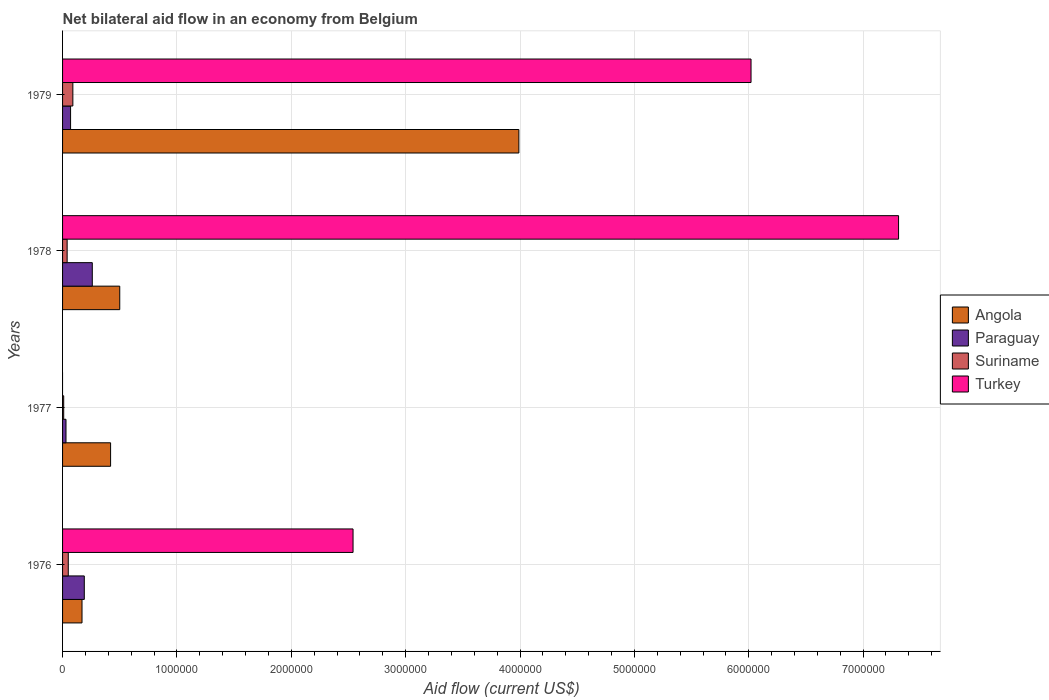Are the number of bars per tick equal to the number of legend labels?
Give a very brief answer. No. What is the label of the 4th group of bars from the top?
Ensure brevity in your answer.  1976. In how many cases, is the number of bars for a given year not equal to the number of legend labels?
Your response must be concise. 1. In which year was the net bilateral aid flow in Turkey maximum?
Offer a very short reply. 1978. What is the total net bilateral aid flow in Suriname in the graph?
Offer a terse response. 1.90e+05. What is the average net bilateral aid flow in Turkey per year?
Your answer should be compact. 3.97e+06. In how many years, is the net bilateral aid flow in Paraguay greater than 3800000 US$?
Your answer should be compact. 0. What is the ratio of the net bilateral aid flow in Paraguay in 1976 to that in 1977?
Keep it short and to the point. 6.33. Is the difference between the net bilateral aid flow in Paraguay in 1978 and 1979 greater than the difference between the net bilateral aid flow in Suriname in 1978 and 1979?
Provide a succinct answer. Yes. What is the difference between the highest and the second highest net bilateral aid flow in Angola?
Keep it short and to the point. 3.49e+06. What is the difference between the highest and the lowest net bilateral aid flow in Angola?
Give a very brief answer. 3.82e+06. In how many years, is the net bilateral aid flow in Angola greater than the average net bilateral aid flow in Angola taken over all years?
Make the answer very short. 1. Is it the case that in every year, the sum of the net bilateral aid flow in Angola and net bilateral aid flow in Turkey is greater than the sum of net bilateral aid flow in Paraguay and net bilateral aid flow in Suriname?
Provide a succinct answer. Yes. Is it the case that in every year, the sum of the net bilateral aid flow in Turkey and net bilateral aid flow in Angola is greater than the net bilateral aid flow in Paraguay?
Your answer should be compact. Yes. How many bars are there?
Provide a succinct answer. 15. How many years are there in the graph?
Keep it short and to the point. 4. Does the graph contain grids?
Keep it short and to the point. Yes. How are the legend labels stacked?
Your response must be concise. Vertical. What is the title of the graph?
Make the answer very short. Net bilateral aid flow in an economy from Belgium. What is the label or title of the X-axis?
Offer a terse response. Aid flow (current US$). What is the label or title of the Y-axis?
Your response must be concise. Years. What is the Aid flow (current US$) of Angola in 1976?
Give a very brief answer. 1.70e+05. What is the Aid flow (current US$) of Turkey in 1976?
Provide a short and direct response. 2.54e+06. What is the Aid flow (current US$) of Angola in 1977?
Provide a succinct answer. 4.20e+05. What is the Aid flow (current US$) in Suriname in 1977?
Your answer should be compact. 10000. What is the Aid flow (current US$) in Paraguay in 1978?
Provide a short and direct response. 2.60e+05. What is the Aid flow (current US$) in Turkey in 1978?
Provide a short and direct response. 7.31e+06. What is the Aid flow (current US$) in Angola in 1979?
Offer a terse response. 3.99e+06. What is the Aid flow (current US$) in Turkey in 1979?
Provide a succinct answer. 6.02e+06. Across all years, what is the maximum Aid flow (current US$) of Angola?
Your answer should be compact. 3.99e+06. Across all years, what is the maximum Aid flow (current US$) in Turkey?
Give a very brief answer. 7.31e+06. Across all years, what is the minimum Aid flow (current US$) of Angola?
Offer a very short reply. 1.70e+05. Across all years, what is the minimum Aid flow (current US$) of Paraguay?
Offer a terse response. 3.00e+04. Across all years, what is the minimum Aid flow (current US$) of Suriname?
Offer a very short reply. 10000. What is the total Aid flow (current US$) of Angola in the graph?
Provide a short and direct response. 5.08e+06. What is the total Aid flow (current US$) of Suriname in the graph?
Provide a short and direct response. 1.90e+05. What is the total Aid flow (current US$) in Turkey in the graph?
Ensure brevity in your answer.  1.59e+07. What is the difference between the Aid flow (current US$) of Angola in 1976 and that in 1978?
Offer a very short reply. -3.30e+05. What is the difference between the Aid flow (current US$) in Paraguay in 1976 and that in 1978?
Offer a very short reply. -7.00e+04. What is the difference between the Aid flow (current US$) in Turkey in 1976 and that in 1978?
Keep it short and to the point. -4.77e+06. What is the difference between the Aid flow (current US$) in Angola in 1976 and that in 1979?
Provide a short and direct response. -3.82e+06. What is the difference between the Aid flow (current US$) in Paraguay in 1976 and that in 1979?
Give a very brief answer. 1.20e+05. What is the difference between the Aid flow (current US$) in Turkey in 1976 and that in 1979?
Ensure brevity in your answer.  -3.48e+06. What is the difference between the Aid flow (current US$) of Angola in 1977 and that in 1978?
Offer a very short reply. -8.00e+04. What is the difference between the Aid flow (current US$) in Suriname in 1977 and that in 1978?
Offer a terse response. -3.00e+04. What is the difference between the Aid flow (current US$) in Angola in 1977 and that in 1979?
Your response must be concise. -3.57e+06. What is the difference between the Aid flow (current US$) of Paraguay in 1977 and that in 1979?
Offer a very short reply. -4.00e+04. What is the difference between the Aid flow (current US$) in Suriname in 1977 and that in 1979?
Give a very brief answer. -8.00e+04. What is the difference between the Aid flow (current US$) in Angola in 1978 and that in 1979?
Make the answer very short. -3.49e+06. What is the difference between the Aid flow (current US$) in Turkey in 1978 and that in 1979?
Your response must be concise. 1.29e+06. What is the difference between the Aid flow (current US$) of Angola in 1976 and the Aid flow (current US$) of Paraguay in 1977?
Keep it short and to the point. 1.40e+05. What is the difference between the Aid flow (current US$) in Angola in 1976 and the Aid flow (current US$) in Suriname in 1978?
Your answer should be compact. 1.30e+05. What is the difference between the Aid flow (current US$) of Angola in 1976 and the Aid flow (current US$) of Turkey in 1978?
Your answer should be compact. -7.14e+06. What is the difference between the Aid flow (current US$) of Paraguay in 1976 and the Aid flow (current US$) of Turkey in 1978?
Your answer should be very brief. -7.12e+06. What is the difference between the Aid flow (current US$) of Suriname in 1976 and the Aid flow (current US$) of Turkey in 1978?
Keep it short and to the point. -7.26e+06. What is the difference between the Aid flow (current US$) of Angola in 1976 and the Aid flow (current US$) of Paraguay in 1979?
Your answer should be very brief. 1.00e+05. What is the difference between the Aid flow (current US$) in Angola in 1976 and the Aid flow (current US$) in Turkey in 1979?
Provide a succinct answer. -5.85e+06. What is the difference between the Aid flow (current US$) of Paraguay in 1976 and the Aid flow (current US$) of Suriname in 1979?
Your answer should be compact. 1.00e+05. What is the difference between the Aid flow (current US$) in Paraguay in 1976 and the Aid flow (current US$) in Turkey in 1979?
Give a very brief answer. -5.83e+06. What is the difference between the Aid flow (current US$) of Suriname in 1976 and the Aid flow (current US$) of Turkey in 1979?
Make the answer very short. -5.97e+06. What is the difference between the Aid flow (current US$) in Angola in 1977 and the Aid flow (current US$) in Suriname in 1978?
Offer a very short reply. 3.80e+05. What is the difference between the Aid flow (current US$) in Angola in 1977 and the Aid flow (current US$) in Turkey in 1978?
Provide a short and direct response. -6.89e+06. What is the difference between the Aid flow (current US$) in Paraguay in 1977 and the Aid flow (current US$) in Turkey in 1978?
Offer a terse response. -7.28e+06. What is the difference between the Aid flow (current US$) in Suriname in 1977 and the Aid flow (current US$) in Turkey in 1978?
Your answer should be very brief. -7.30e+06. What is the difference between the Aid flow (current US$) in Angola in 1977 and the Aid flow (current US$) in Paraguay in 1979?
Your response must be concise. 3.50e+05. What is the difference between the Aid flow (current US$) in Angola in 1977 and the Aid flow (current US$) in Suriname in 1979?
Provide a short and direct response. 3.30e+05. What is the difference between the Aid flow (current US$) of Angola in 1977 and the Aid flow (current US$) of Turkey in 1979?
Keep it short and to the point. -5.60e+06. What is the difference between the Aid flow (current US$) in Paraguay in 1977 and the Aid flow (current US$) in Turkey in 1979?
Your answer should be very brief. -5.99e+06. What is the difference between the Aid flow (current US$) in Suriname in 1977 and the Aid flow (current US$) in Turkey in 1979?
Your response must be concise. -6.01e+06. What is the difference between the Aid flow (current US$) in Angola in 1978 and the Aid flow (current US$) in Paraguay in 1979?
Give a very brief answer. 4.30e+05. What is the difference between the Aid flow (current US$) of Angola in 1978 and the Aid flow (current US$) of Turkey in 1979?
Keep it short and to the point. -5.52e+06. What is the difference between the Aid flow (current US$) of Paraguay in 1978 and the Aid flow (current US$) of Turkey in 1979?
Your answer should be very brief. -5.76e+06. What is the difference between the Aid flow (current US$) of Suriname in 1978 and the Aid flow (current US$) of Turkey in 1979?
Provide a succinct answer. -5.98e+06. What is the average Aid flow (current US$) of Angola per year?
Make the answer very short. 1.27e+06. What is the average Aid flow (current US$) in Paraguay per year?
Offer a terse response. 1.38e+05. What is the average Aid flow (current US$) in Suriname per year?
Keep it short and to the point. 4.75e+04. What is the average Aid flow (current US$) in Turkey per year?
Make the answer very short. 3.97e+06. In the year 1976, what is the difference between the Aid flow (current US$) of Angola and Aid flow (current US$) of Paraguay?
Keep it short and to the point. -2.00e+04. In the year 1976, what is the difference between the Aid flow (current US$) in Angola and Aid flow (current US$) in Turkey?
Provide a short and direct response. -2.37e+06. In the year 1976, what is the difference between the Aid flow (current US$) of Paraguay and Aid flow (current US$) of Suriname?
Keep it short and to the point. 1.40e+05. In the year 1976, what is the difference between the Aid flow (current US$) of Paraguay and Aid flow (current US$) of Turkey?
Your answer should be very brief. -2.35e+06. In the year 1976, what is the difference between the Aid flow (current US$) in Suriname and Aid flow (current US$) in Turkey?
Your answer should be compact. -2.49e+06. In the year 1977, what is the difference between the Aid flow (current US$) in Angola and Aid flow (current US$) in Paraguay?
Your answer should be compact. 3.90e+05. In the year 1977, what is the difference between the Aid flow (current US$) of Angola and Aid flow (current US$) of Suriname?
Your answer should be compact. 4.10e+05. In the year 1978, what is the difference between the Aid flow (current US$) in Angola and Aid flow (current US$) in Suriname?
Offer a terse response. 4.60e+05. In the year 1978, what is the difference between the Aid flow (current US$) of Angola and Aid flow (current US$) of Turkey?
Give a very brief answer. -6.81e+06. In the year 1978, what is the difference between the Aid flow (current US$) of Paraguay and Aid flow (current US$) of Suriname?
Offer a terse response. 2.20e+05. In the year 1978, what is the difference between the Aid flow (current US$) in Paraguay and Aid flow (current US$) in Turkey?
Your response must be concise. -7.05e+06. In the year 1978, what is the difference between the Aid flow (current US$) of Suriname and Aid flow (current US$) of Turkey?
Your response must be concise. -7.27e+06. In the year 1979, what is the difference between the Aid flow (current US$) of Angola and Aid flow (current US$) of Paraguay?
Ensure brevity in your answer.  3.92e+06. In the year 1979, what is the difference between the Aid flow (current US$) in Angola and Aid flow (current US$) in Suriname?
Provide a succinct answer. 3.90e+06. In the year 1979, what is the difference between the Aid flow (current US$) in Angola and Aid flow (current US$) in Turkey?
Offer a terse response. -2.03e+06. In the year 1979, what is the difference between the Aid flow (current US$) of Paraguay and Aid flow (current US$) of Suriname?
Your answer should be compact. -2.00e+04. In the year 1979, what is the difference between the Aid flow (current US$) of Paraguay and Aid flow (current US$) of Turkey?
Your answer should be compact. -5.95e+06. In the year 1979, what is the difference between the Aid flow (current US$) of Suriname and Aid flow (current US$) of Turkey?
Your response must be concise. -5.93e+06. What is the ratio of the Aid flow (current US$) of Angola in 1976 to that in 1977?
Provide a succinct answer. 0.4. What is the ratio of the Aid flow (current US$) of Paraguay in 1976 to that in 1977?
Your answer should be very brief. 6.33. What is the ratio of the Aid flow (current US$) of Angola in 1976 to that in 1978?
Your answer should be compact. 0.34. What is the ratio of the Aid flow (current US$) in Paraguay in 1976 to that in 1978?
Provide a short and direct response. 0.73. What is the ratio of the Aid flow (current US$) in Turkey in 1976 to that in 1978?
Your answer should be very brief. 0.35. What is the ratio of the Aid flow (current US$) in Angola in 1976 to that in 1979?
Provide a short and direct response. 0.04. What is the ratio of the Aid flow (current US$) of Paraguay in 1976 to that in 1979?
Your answer should be very brief. 2.71. What is the ratio of the Aid flow (current US$) of Suriname in 1976 to that in 1979?
Provide a short and direct response. 0.56. What is the ratio of the Aid flow (current US$) in Turkey in 1976 to that in 1979?
Your answer should be compact. 0.42. What is the ratio of the Aid flow (current US$) in Angola in 1977 to that in 1978?
Your response must be concise. 0.84. What is the ratio of the Aid flow (current US$) in Paraguay in 1977 to that in 1978?
Your answer should be compact. 0.12. What is the ratio of the Aid flow (current US$) in Suriname in 1977 to that in 1978?
Make the answer very short. 0.25. What is the ratio of the Aid flow (current US$) in Angola in 1977 to that in 1979?
Make the answer very short. 0.11. What is the ratio of the Aid flow (current US$) in Paraguay in 1977 to that in 1979?
Your response must be concise. 0.43. What is the ratio of the Aid flow (current US$) in Angola in 1978 to that in 1979?
Ensure brevity in your answer.  0.13. What is the ratio of the Aid flow (current US$) in Paraguay in 1978 to that in 1979?
Make the answer very short. 3.71. What is the ratio of the Aid flow (current US$) of Suriname in 1978 to that in 1979?
Ensure brevity in your answer.  0.44. What is the ratio of the Aid flow (current US$) in Turkey in 1978 to that in 1979?
Your response must be concise. 1.21. What is the difference between the highest and the second highest Aid flow (current US$) in Angola?
Give a very brief answer. 3.49e+06. What is the difference between the highest and the second highest Aid flow (current US$) of Turkey?
Make the answer very short. 1.29e+06. What is the difference between the highest and the lowest Aid flow (current US$) of Angola?
Offer a very short reply. 3.82e+06. What is the difference between the highest and the lowest Aid flow (current US$) in Suriname?
Keep it short and to the point. 8.00e+04. What is the difference between the highest and the lowest Aid flow (current US$) in Turkey?
Your response must be concise. 7.31e+06. 